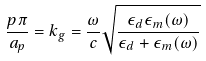<formula> <loc_0><loc_0><loc_500><loc_500>\frac { p \pi } { a _ { p } } = k _ { g } = \frac { \omega } { c } \sqrt { \frac { \epsilon _ { d } \epsilon _ { m } ( \omega ) } { \epsilon _ { d } + \epsilon _ { m } ( \omega ) } }</formula> 